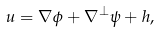<formula> <loc_0><loc_0><loc_500><loc_500>u = \nabla \phi + \nabla ^ { \perp } \psi + h ,</formula> 